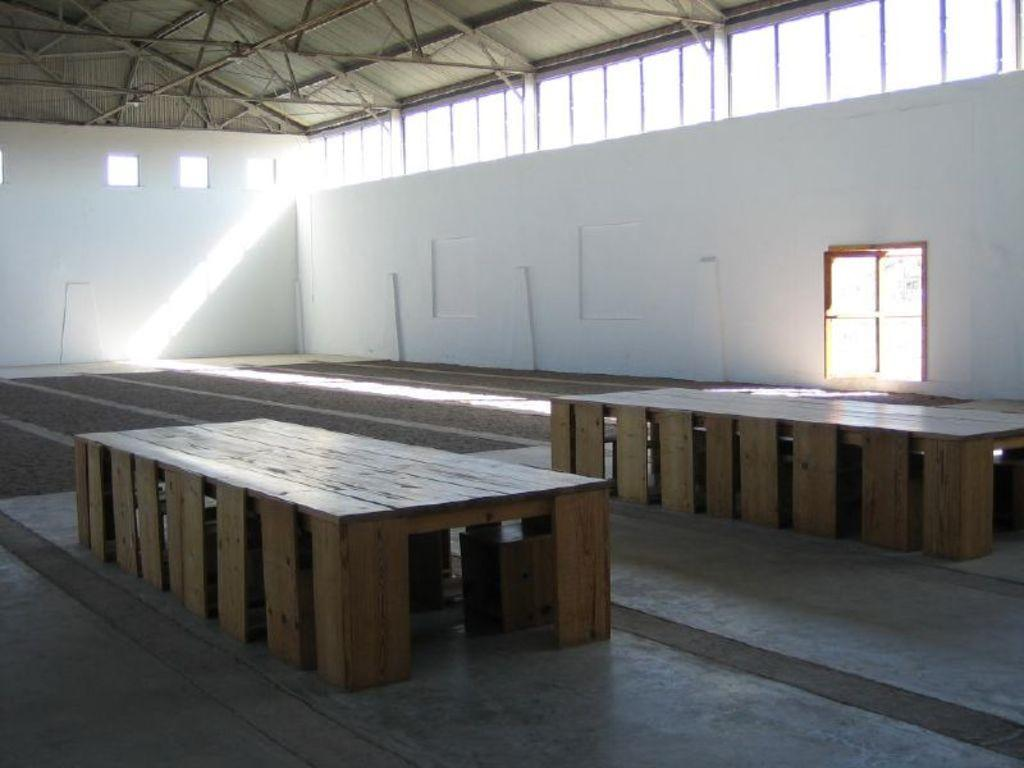How many tables can be seen in the image? There are two tables in the image. What material are the tables made of? The tables are made of wood. What color are the walls in the image? The walls in the image are white. What architectural features are present in the image? There is a door and windows in the image. Can you see a girl wearing a cap in the image? There is no girl wearing a cap present in the image. What type of waste is being disposed of in the image? There is no waste being disposed of in the image. 